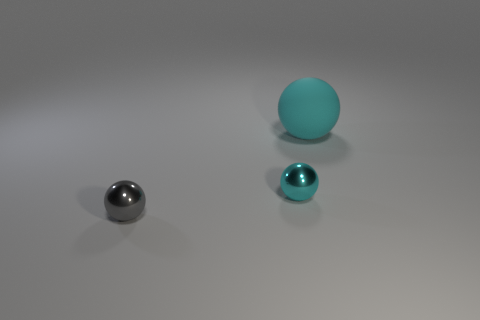What number of other shiny spheres have the same color as the big ball?
Give a very brief answer. 1. What number of other objects are there of the same color as the big ball?
Keep it short and to the point. 1. Are there any other things that have the same material as the gray ball?
Offer a terse response. Yes. What material is the other cyan object that is the same shape as the tiny cyan metal object?
Offer a terse response. Rubber. Is the number of balls that are in front of the small gray metallic ball less than the number of large brown things?
Provide a short and direct response. No. There is a thing in front of the cyan metallic sphere; is its shape the same as the big cyan rubber thing?
Your answer should be very brief. Yes. Are there any other things of the same color as the matte object?
Your answer should be compact. Yes. There is another ball that is made of the same material as the gray ball; what is its size?
Make the answer very short. Small. There is a small ball behind the tiny sphere in front of the cyan sphere that is in front of the big cyan rubber thing; what is it made of?
Your answer should be compact. Metal. Is the number of big red rubber blocks less than the number of big objects?
Your answer should be very brief. Yes. 